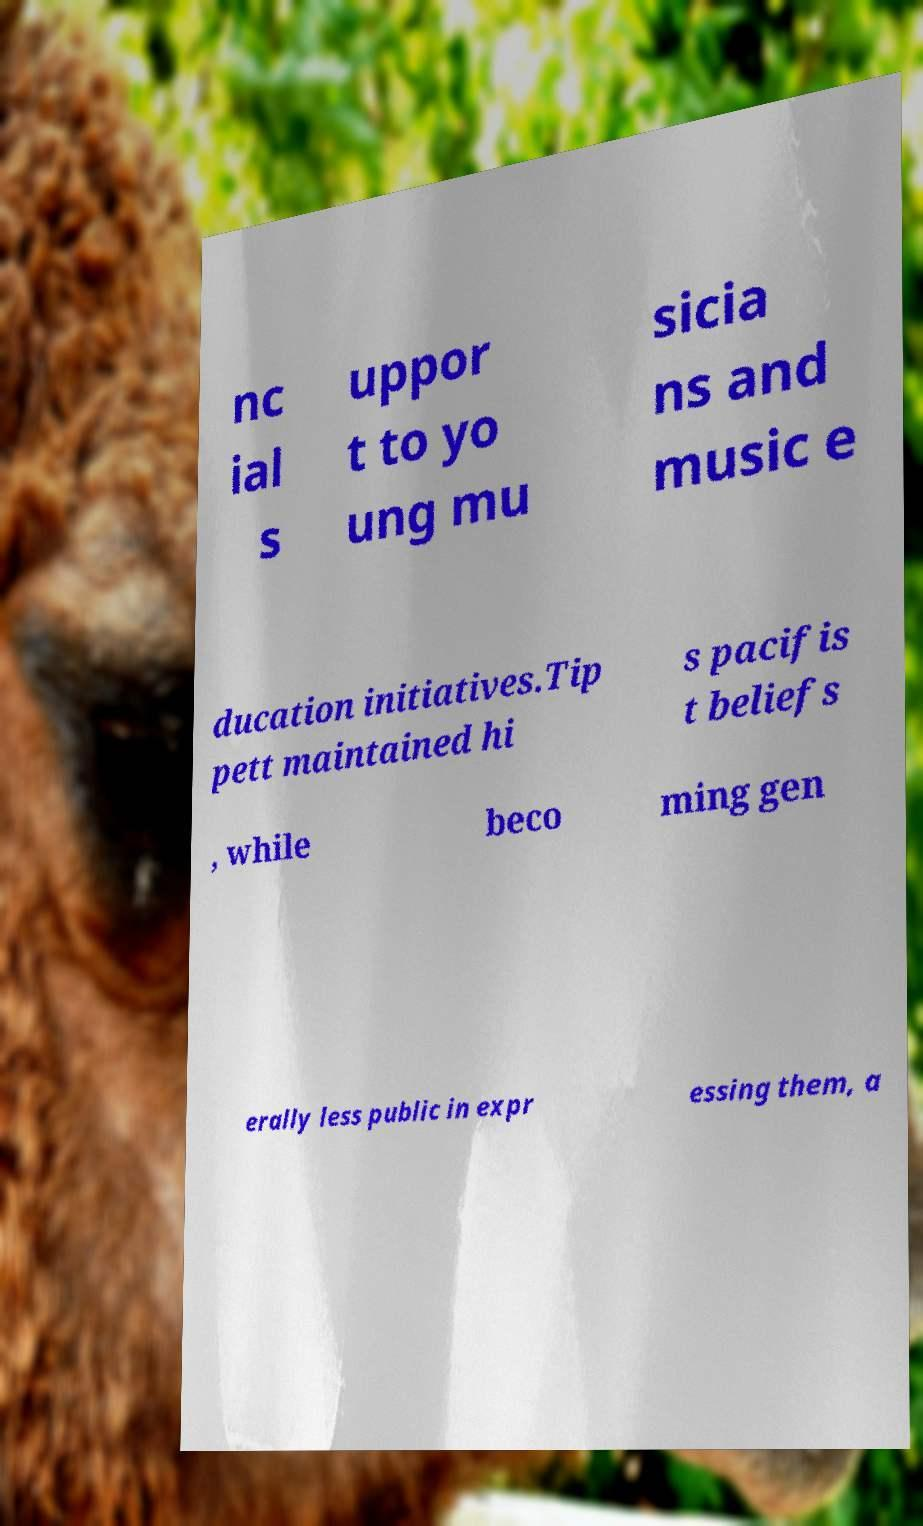Can you accurately transcribe the text from the provided image for me? nc ial s uppor t to yo ung mu sicia ns and music e ducation initiatives.Tip pett maintained hi s pacifis t beliefs , while beco ming gen erally less public in expr essing them, a 